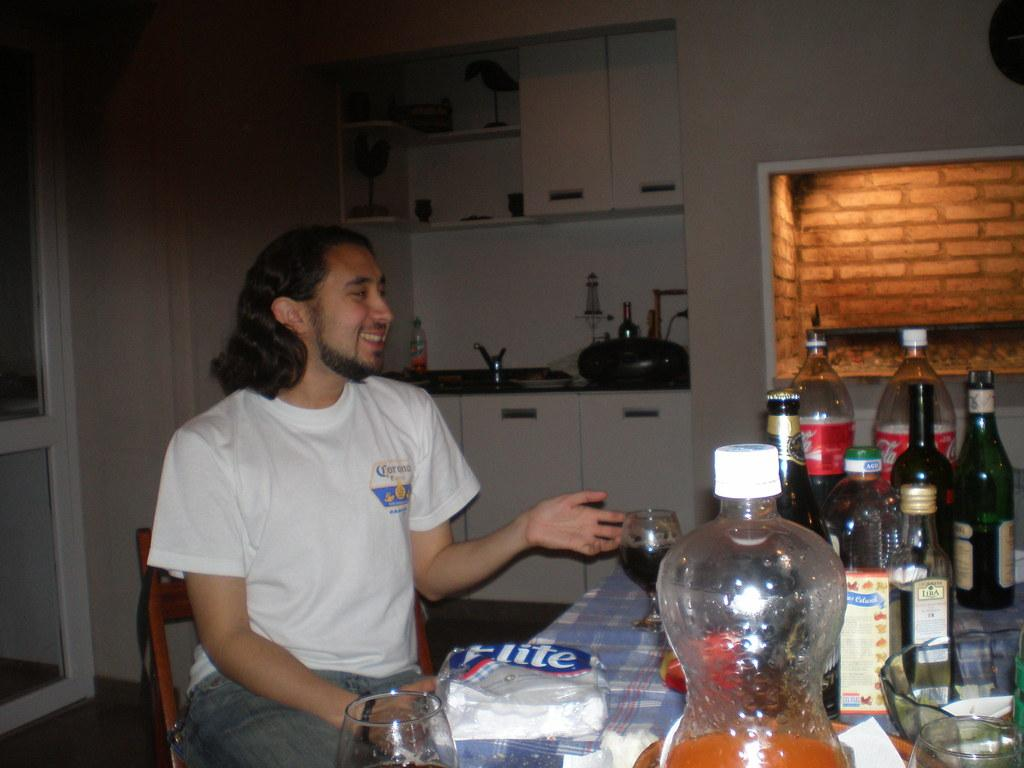What is the man in the image doing? The man is sitting on a chair in the image. What is the man's facial expression? The man is smiling. What can be seen near the man? There are wine bottles in the image. What is on the wine bottles? There are objects on the wine bottles. What type of material is visible in the image? There are bricks in the image. What architectural feature can be seen in the image? There is a door in the image. How many cubs are playing with the bricks in the image? There are no cubs present in the image, and therefore no such activity can be observed. 